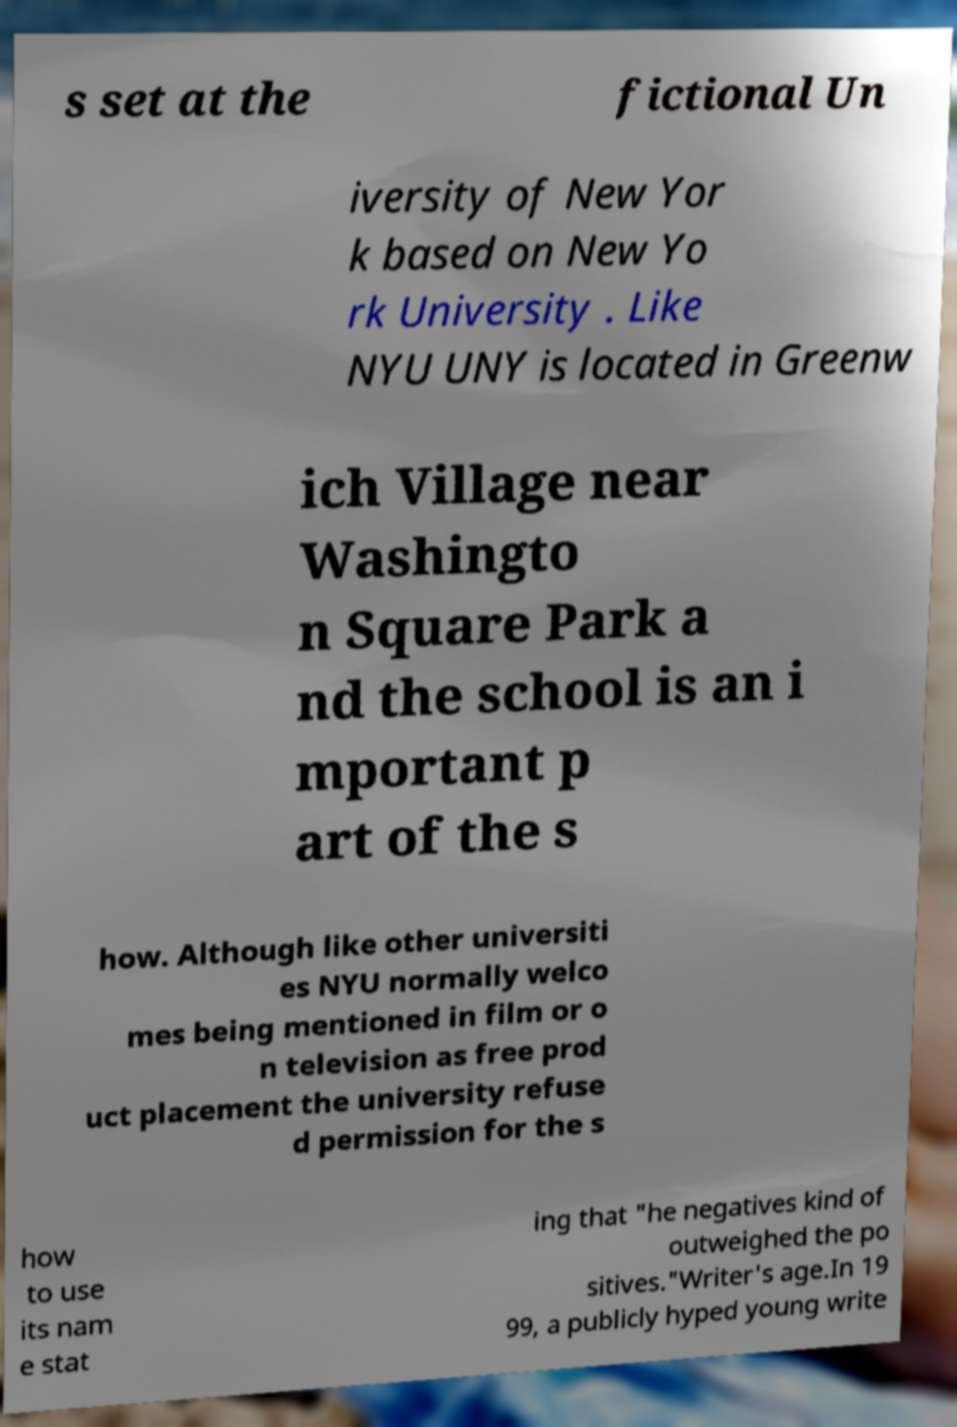Please read and relay the text visible in this image. What does it say? s set at the fictional Un iversity of New Yor k based on New Yo rk University . Like NYU UNY is located in Greenw ich Village near Washingto n Square Park a nd the school is an i mportant p art of the s how. Although like other universiti es NYU normally welco mes being mentioned in film or o n television as free prod uct placement the university refuse d permission for the s how to use its nam e stat ing that "he negatives kind of outweighed the po sitives."Writer's age.In 19 99, a publicly hyped young write 